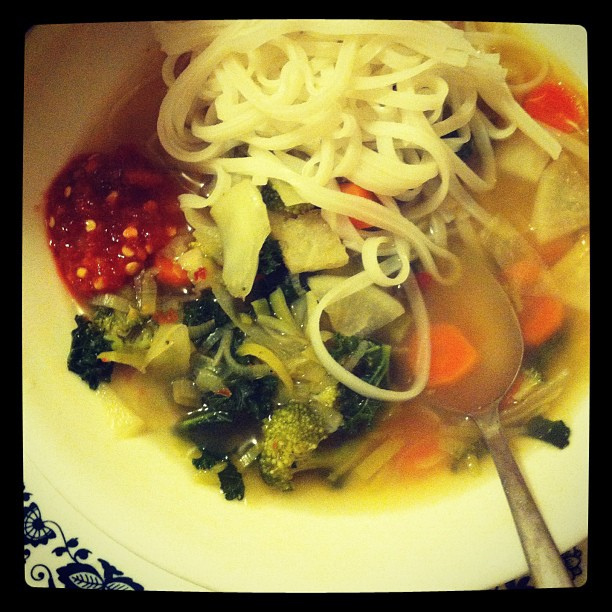<image>What is the brown stuff on the bottom right? I don't know what is the brown stuff on the bottom right. It could be spoon, broth, beans, or carrots. What is the brown stuff on the bottom right? I am not sure what the brown stuff on the bottom right is. It can be seen as 'spoon', 'broth', 'soup broth', 'beans', or 'carrots'. 